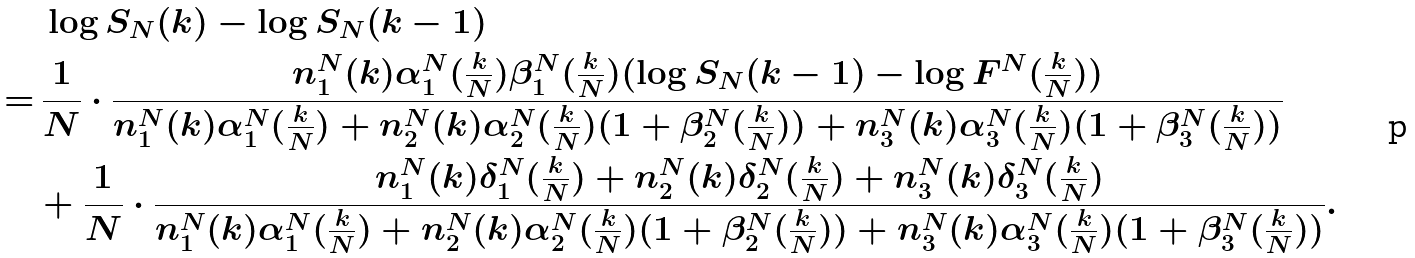Convert formula to latex. <formula><loc_0><loc_0><loc_500><loc_500>& \, \log S _ { N } ( k ) - \log S _ { N } ( k - 1 ) \\ = & \, \frac { 1 } { N } \cdot \frac { n ^ { N } _ { 1 } ( k ) \alpha _ { 1 } ^ { N } ( \frac { k } { N } ) \beta _ { 1 } ^ { N } ( \frac { k } { N } ) ( \log S _ { N } ( k - 1 ) - \log F ^ { N } ( \frac { k } { N } ) ) } { n ^ { N } _ { 1 } ( k ) \alpha _ { 1 } ^ { N } ( \frac { k } { N } ) + n ^ { N } _ { 2 } ( k ) \alpha _ { 2 } ^ { N } ( \frac { k } { N } ) ( 1 + \beta _ { 2 } ^ { N } ( \frac { k } { N } ) ) + n ^ { N } _ { 3 } ( k ) \alpha _ { 3 } ^ { N } ( \frac { k } { N } ) ( 1 + \beta _ { 3 } ^ { N } ( \frac { k } { N } ) ) } \\ & + \frac { 1 } { N } \cdot \frac { n ^ { N } _ { 1 } ( k ) \delta ^ { N } _ { 1 } ( \frac { k } { N } ) + n ^ { N } _ { 2 } ( k ) \delta ^ { N } _ { 2 } ( \frac { k } { N } ) + n ^ { N } _ { 3 } ( k ) \delta ^ { N } _ { 3 } ( \frac { k } { N } ) } { n ^ { N } _ { 1 } ( k ) \alpha _ { 1 } ^ { N } ( \frac { k } { N } ) + n ^ { N } _ { 2 } ( k ) \alpha _ { 2 } ^ { N } ( \frac { k } { N } ) ( 1 + \beta _ { 2 } ^ { N } ( \frac { k } { N } ) ) + n ^ { N } _ { 3 } ( k ) \alpha _ { 3 } ^ { N } ( \frac { k } { N } ) ( 1 + \beta _ { 3 } ^ { N } ( \frac { k } { N } ) ) } .</formula> 